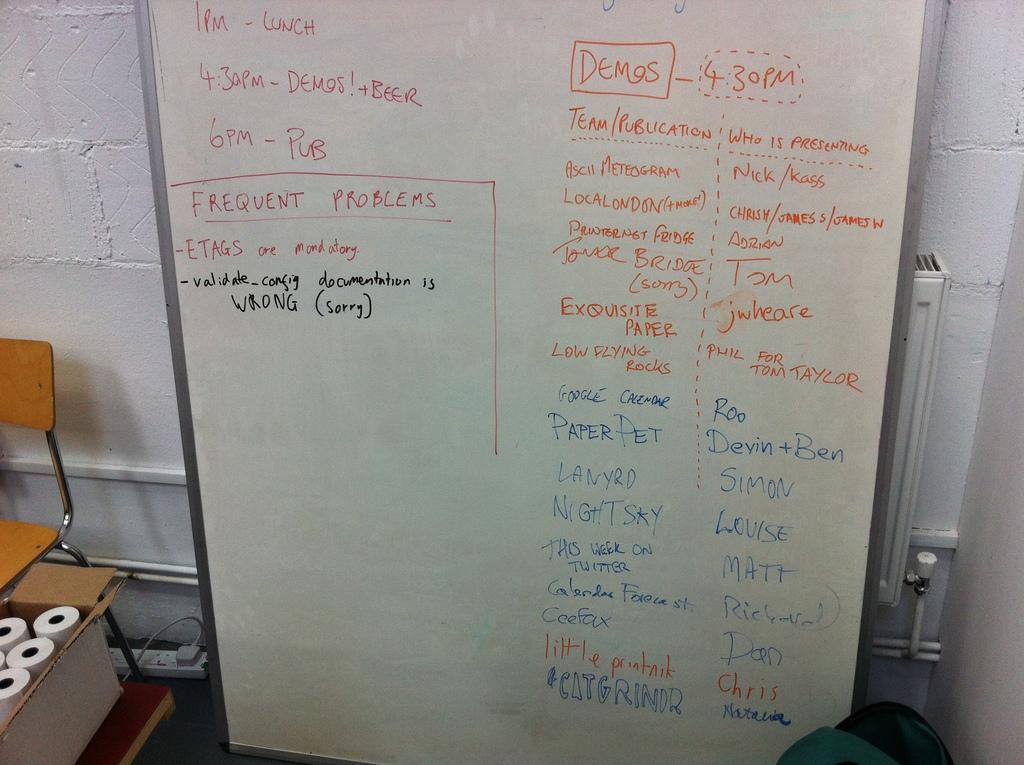Provide a one-sentence caption for the provided image. A white dry erase board with a 1 PM lunch scheduled. 